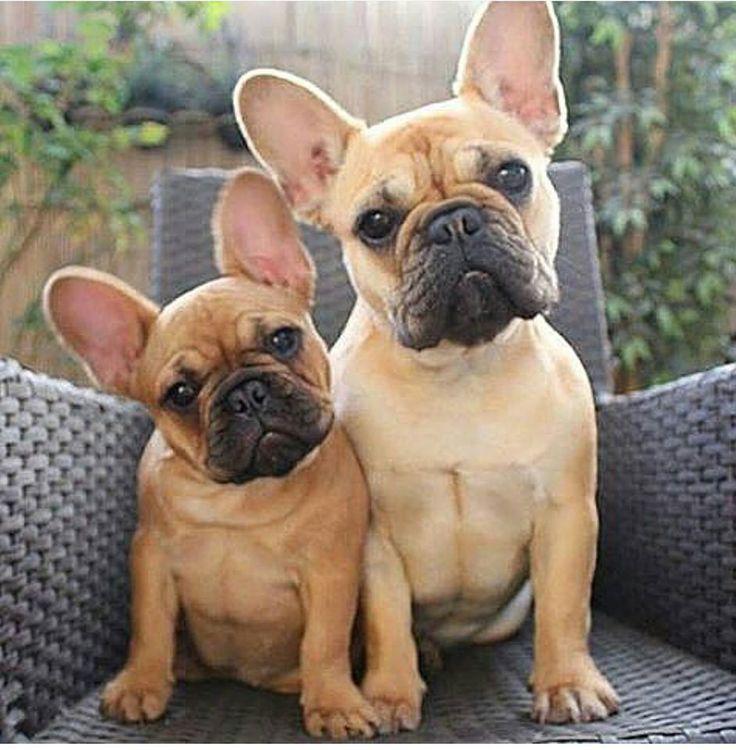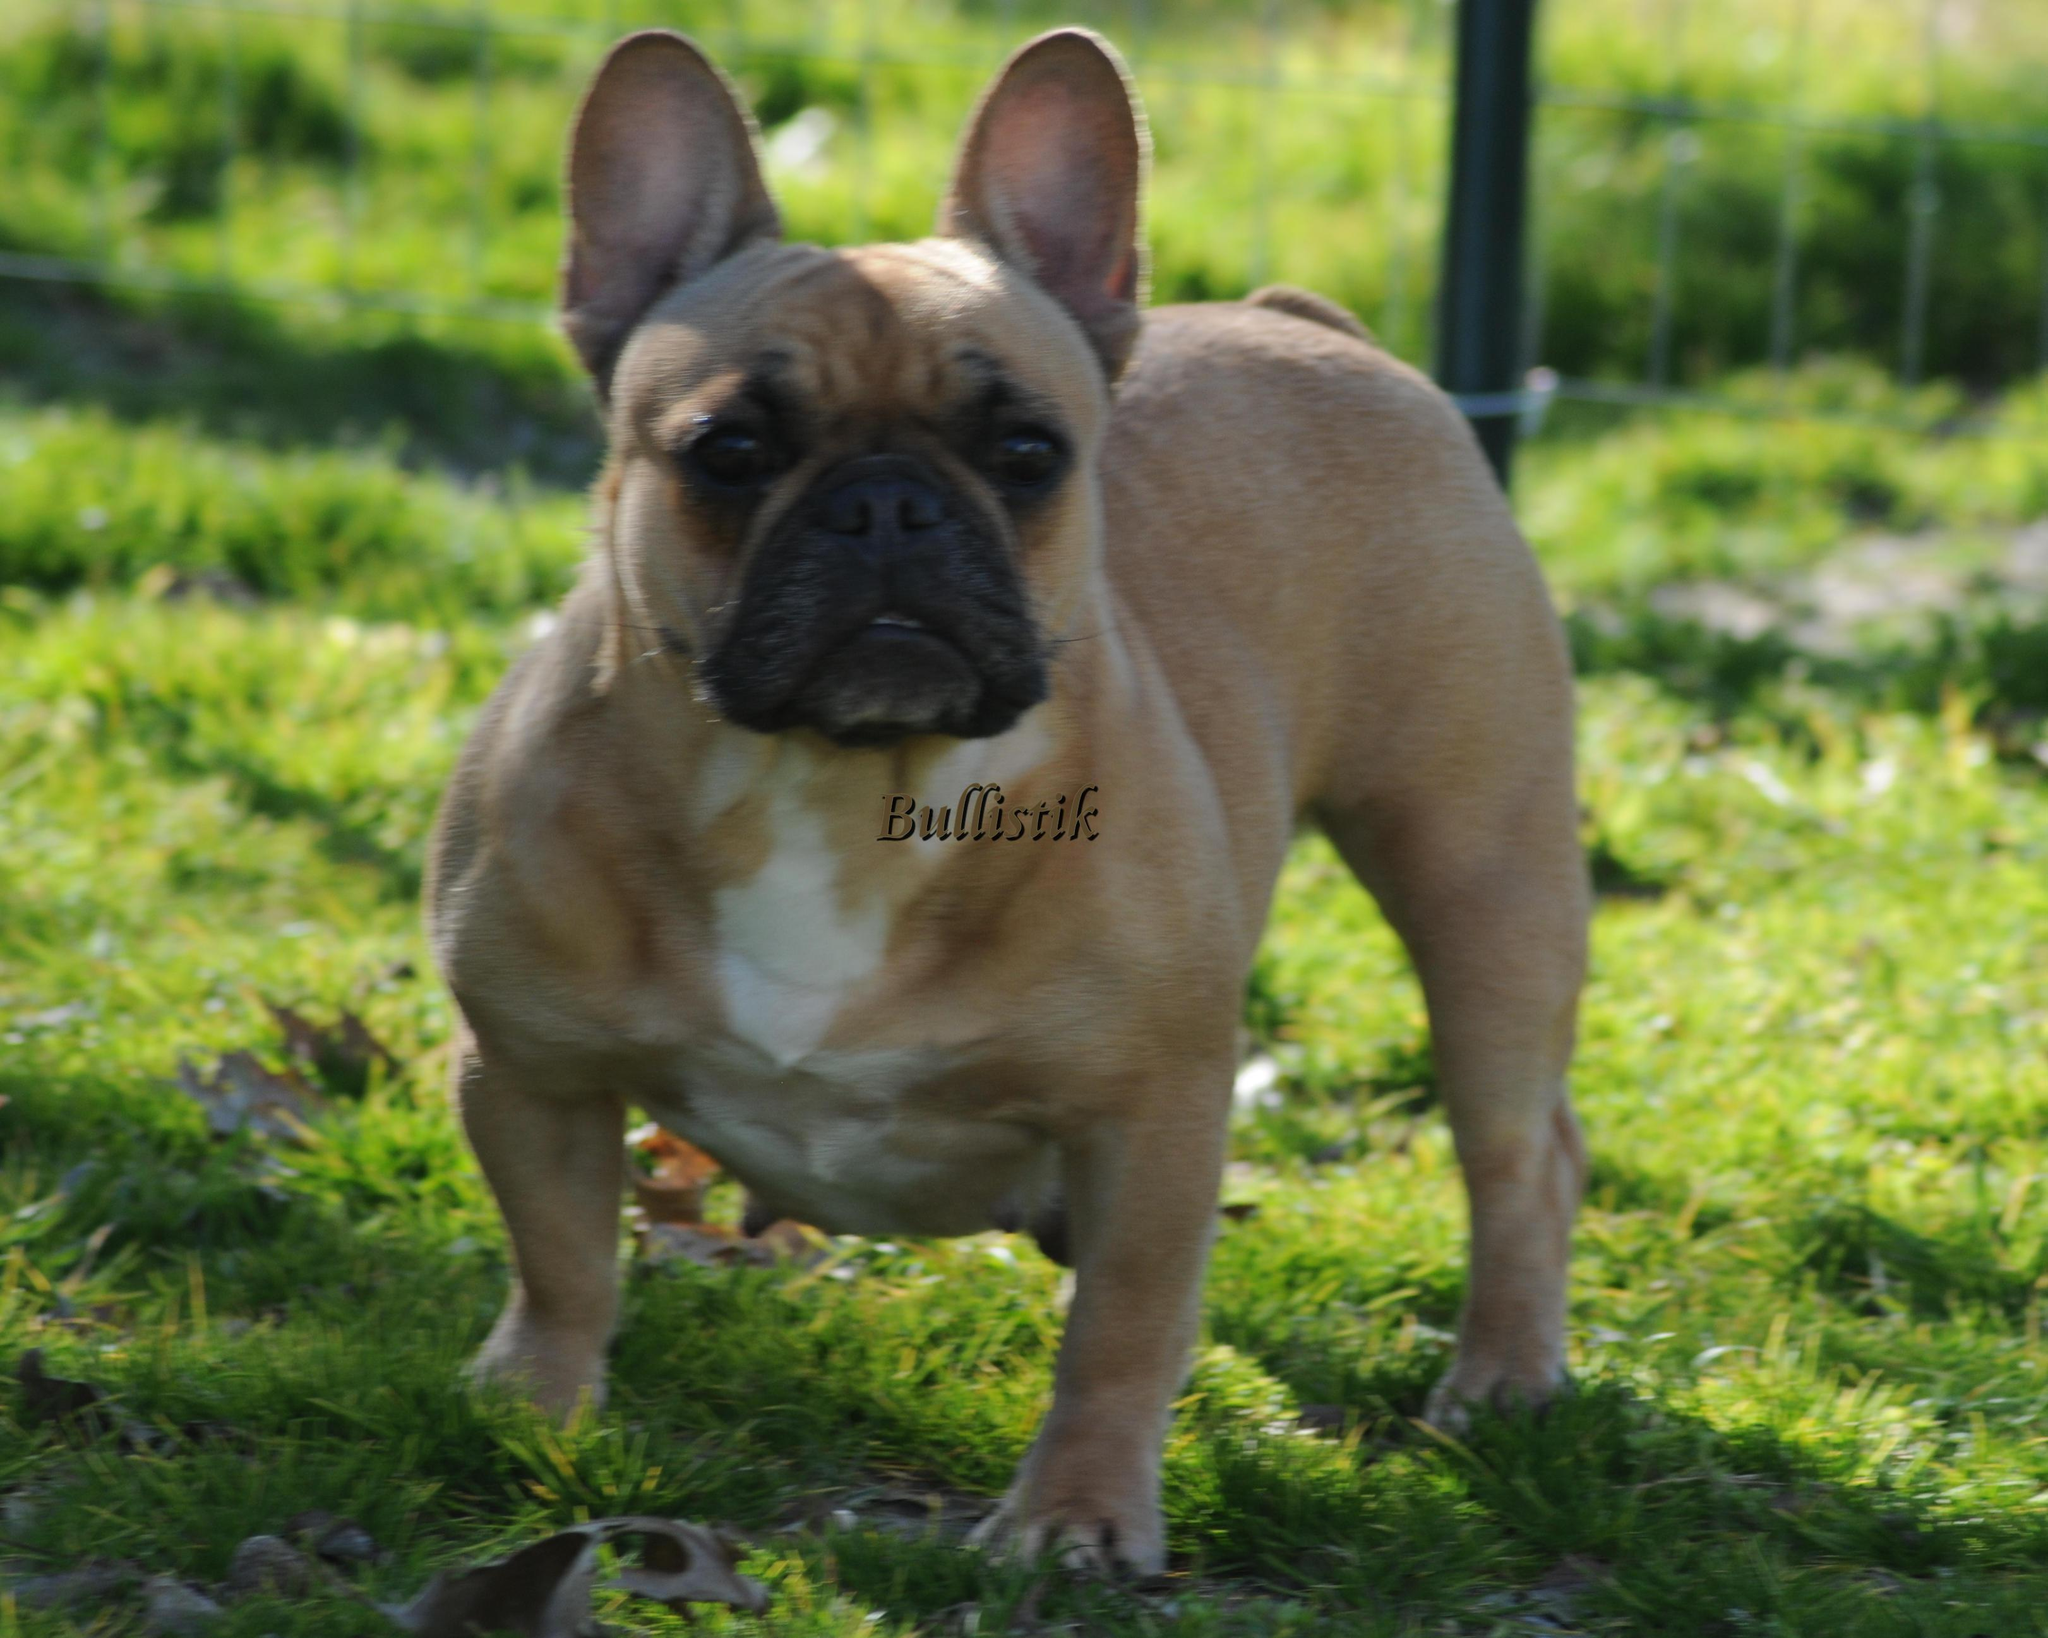The first image is the image on the left, the second image is the image on the right. Evaluate the accuracy of this statement regarding the images: "All of the dogs are dark colored, and the right image contains twice the dogs as the left image.". Is it true? Answer yes or no. No. The first image is the image on the left, the second image is the image on the right. Given the left and right images, does the statement "There are two dogs in the grass." hold true? Answer yes or no. No. 